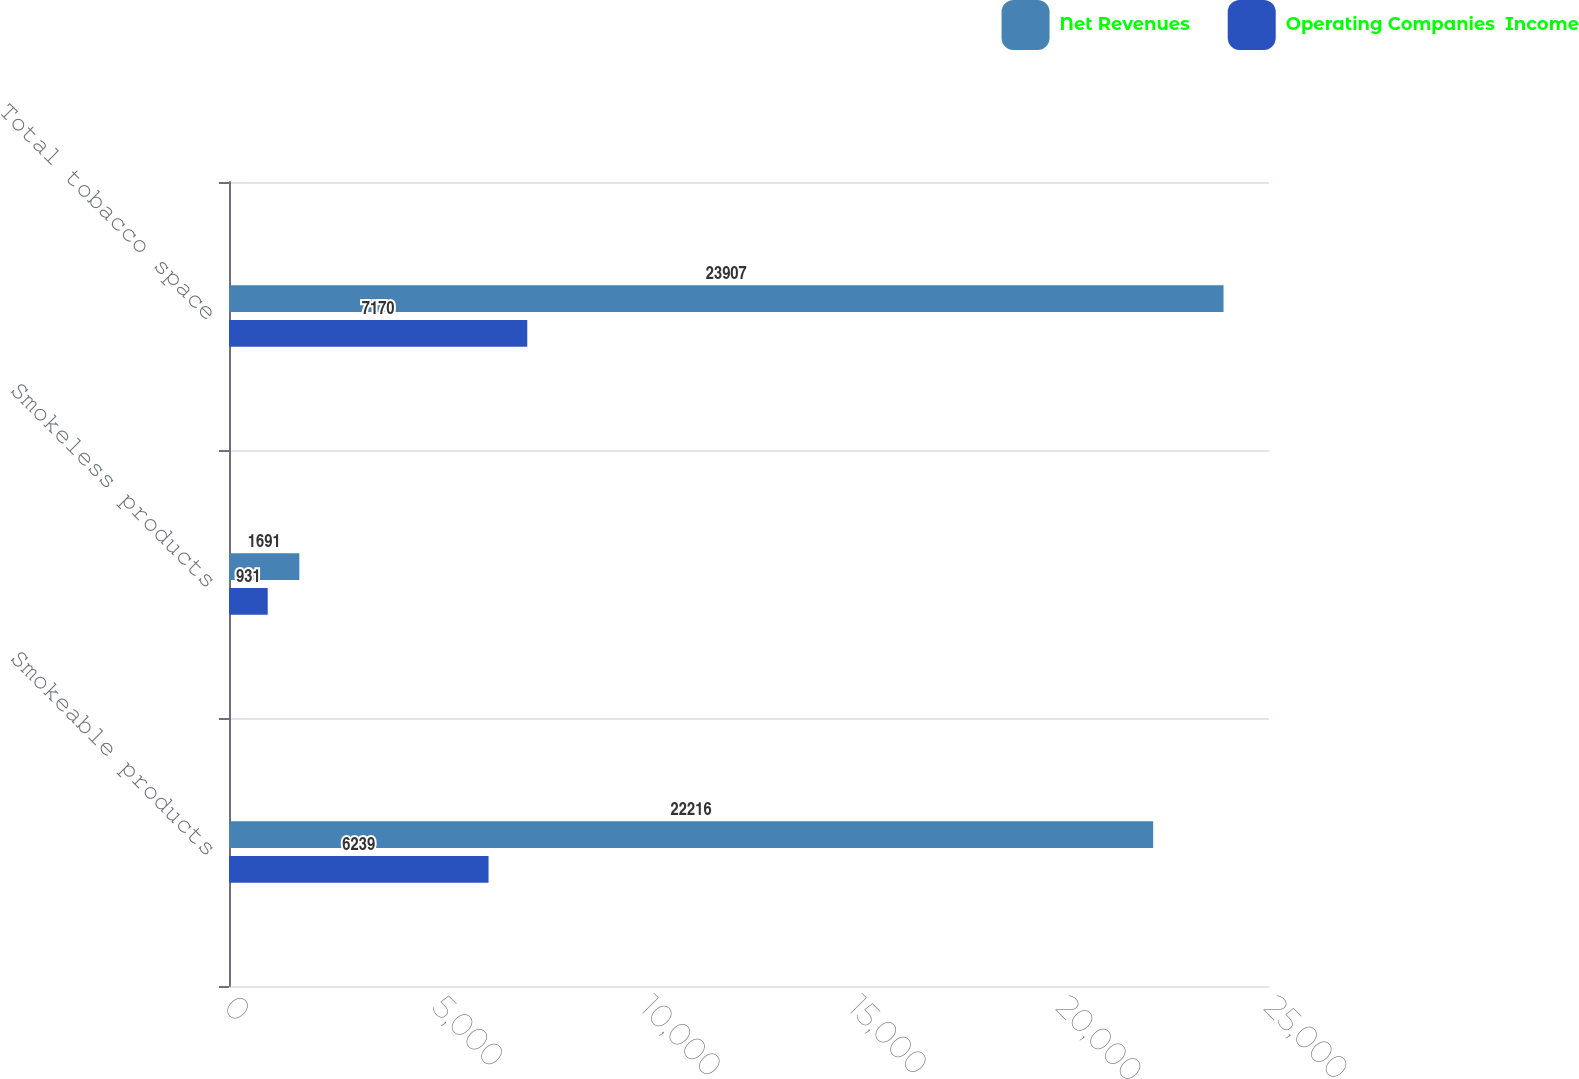Convert chart to OTSL. <chart><loc_0><loc_0><loc_500><loc_500><stacked_bar_chart><ecel><fcel>Smokeable products<fcel>Smokeless products<fcel>Total tobacco space<nl><fcel>Net Revenues<fcel>22216<fcel>1691<fcel>23907<nl><fcel>Operating Companies  Income<fcel>6239<fcel>931<fcel>7170<nl></chart> 